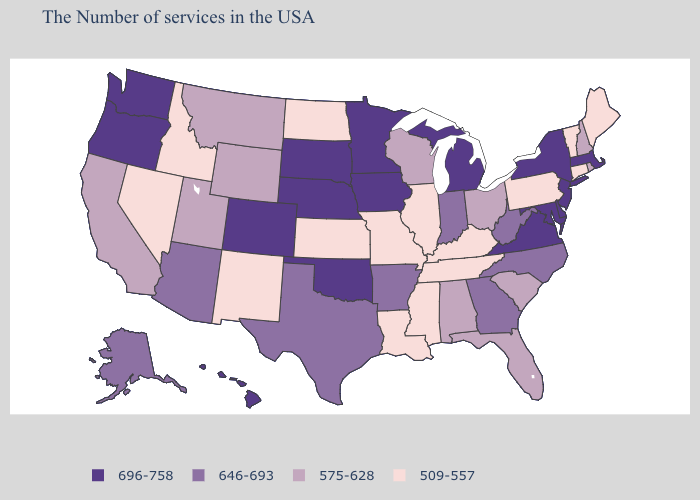Does the map have missing data?
Be succinct. No. Does the map have missing data?
Give a very brief answer. No. Among the states that border Arkansas , does Louisiana have the highest value?
Write a very short answer. No. Name the states that have a value in the range 696-758?
Be succinct. Massachusetts, New York, New Jersey, Delaware, Maryland, Virginia, Michigan, Minnesota, Iowa, Nebraska, Oklahoma, South Dakota, Colorado, Washington, Oregon, Hawaii. What is the value of Maine?
Short answer required. 509-557. Name the states that have a value in the range 575-628?
Keep it brief. Rhode Island, New Hampshire, South Carolina, Ohio, Florida, Alabama, Wisconsin, Wyoming, Utah, Montana, California. Which states have the highest value in the USA?
Write a very short answer. Massachusetts, New York, New Jersey, Delaware, Maryland, Virginia, Michigan, Minnesota, Iowa, Nebraska, Oklahoma, South Dakota, Colorado, Washington, Oregon, Hawaii. Does South Carolina have a higher value than Minnesota?
Give a very brief answer. No. What is the value of Delaware?
Quick response, please. 696-758. Which states hav the highest value in the West?
Concise answer only. Colorado, Washington, Oregon, Hawaii. What is the value of Iowa?
Write a very short answer. 696-758. Does Maryland have the lowest value in the South?
Quick response, please. No. Name the states that have a value in the range 575-628?
Be succinct. Rhode Island, New Hampshire, South Carolina, Ohio, Florida, Alabama, Wisconsin, Wyoming, Utah, Montana, California. Does Kentucky have the lowest value in the South?
Keep it brief. Yes. What is the value of Illinois?
Concise answer only. 509-557. 